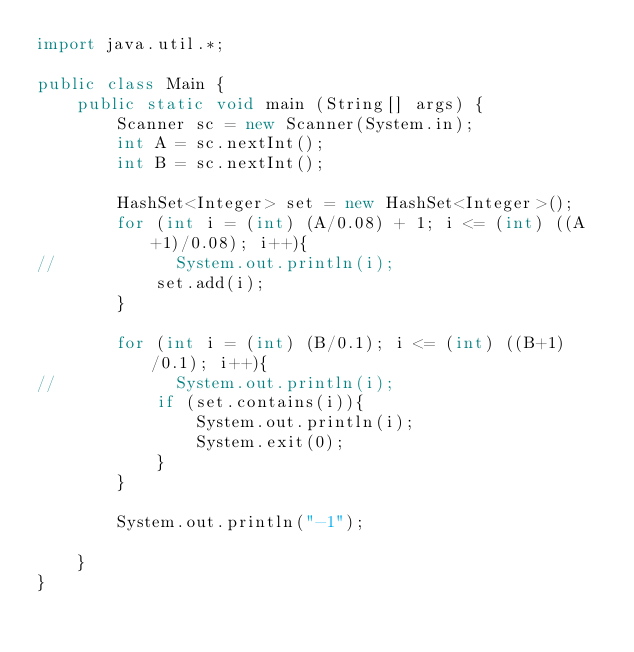Convert code to text. <code><loc_0><loc_0><loc_500><loc_500><_Java_>import java.util.*;

public class Main {
    public static void main (String[] args) {
        Scanner sc = new Scanner(System.in);
        int A = sc.nextInt();
        int B = sc.nextInt();

        HashSet<Integer> set = new HashSet<Integer>();
        for (int i = (int) (A/0.08) + 1; i <= (int) ((A+1)/0.08); i++){
//            System.out.println(i);
            set.add(i);
        }

        for (int i = (int) (B/0.1); i <= (int) ((B+1)/0.1); i++){
//            System.out.println(i);
            if (set.contains(i)){
                System.out.println(i);
                System.exit(0);
            }
        }

        System.out.println("-1");

    }
}</code> 